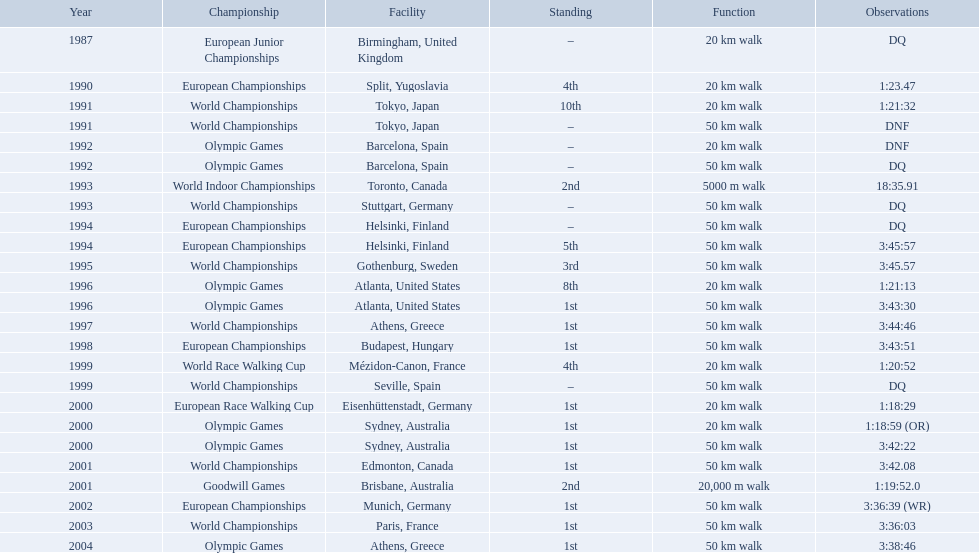Which of the competitions were 50 km walks? World Championships, Olympic Games, World Championships, European Championships, European Championships, World Championships, Olympic Games, World Championships, European Championships, World Championships, Olympic Games, World Championships, European Championships, World Championships, Olympic Games. Of these, which took place during or after the year 2000? Olympic Games, World Championships, European Championships, World Championships, Olympic Games. From these, which took place in athens, greece? Olympic Games. What was the time to finish for this competition? 3:38:46. What are the notes DQ, 1:23.47, 1:21:32, DNF, DNF, DQ, 18:35.91, DQ, DQ, 3:45:57, 3:45.57, 1:21:13, 3:43:30, 3:44:46, 3:43:51, 1:20:52, DQ, 1:18:29, 1:18:59 (OR), 3:42:22, 3:42.08, 1:19:52.0, 3:36:39 (WR), 3:36:03, 3:38:46. What time does the notes for 2004 show 3:38:46. 